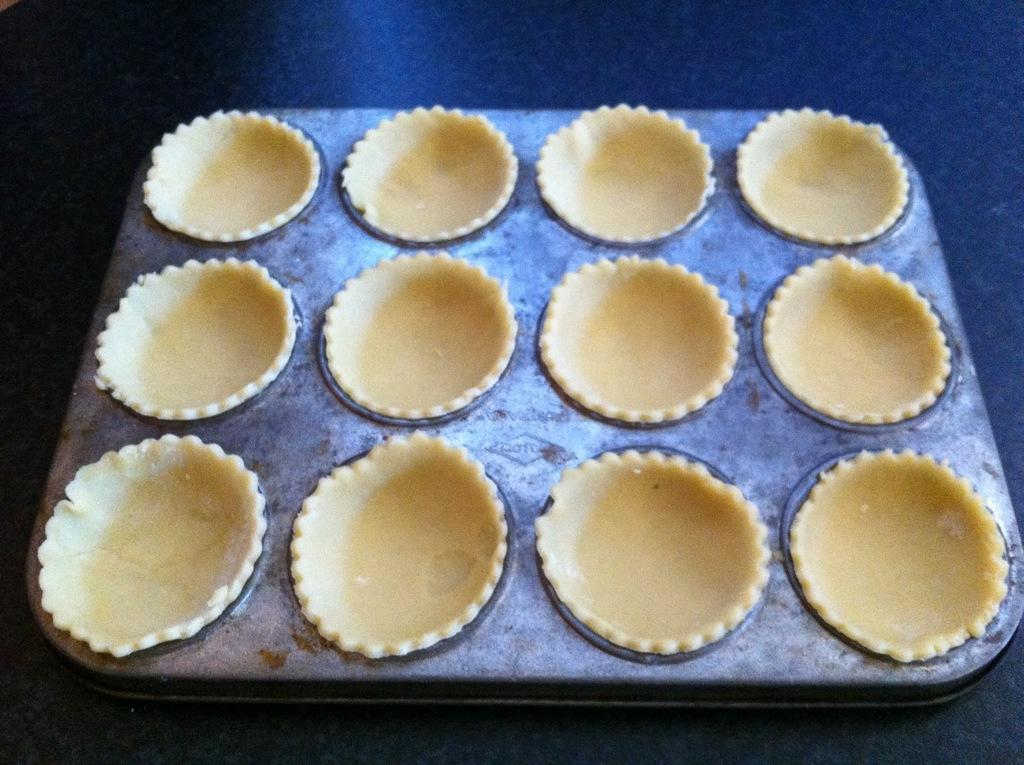What is the main object in the image? There is a muffin mould in the image. Where is the muffin mould located? The muffin mould is placed on a table. What type of land can be seen in the background of the image? There is no land visible in the image, as it only features a muffin mould placed on a table. 